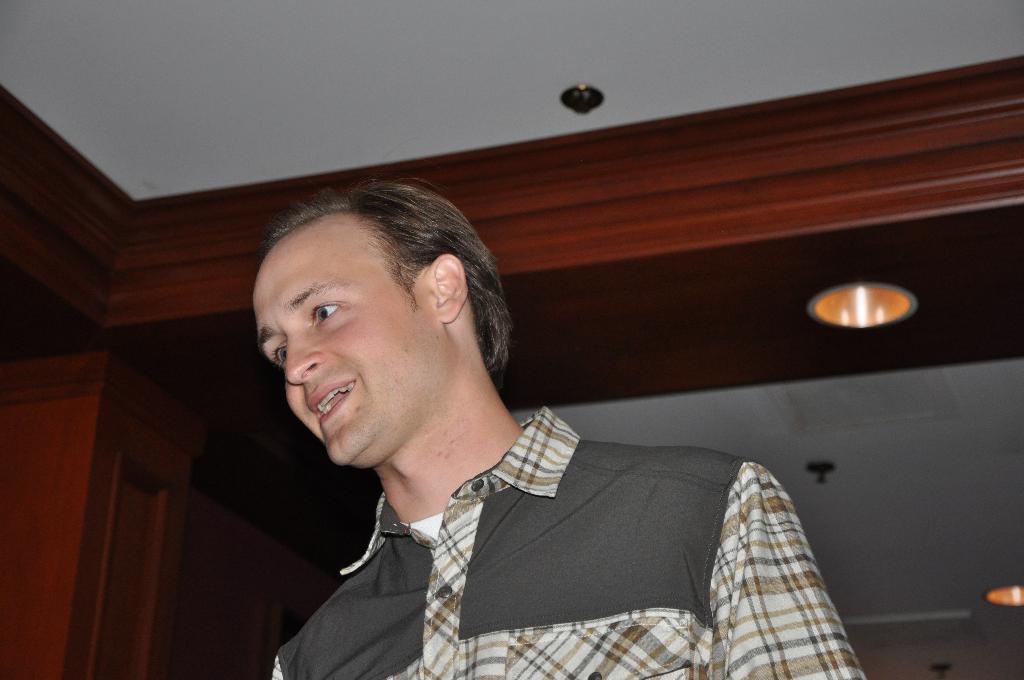In one or two sentences, can you explain what this image depicts? In this image we can see a person. At the top of the image there is a ceiling. 